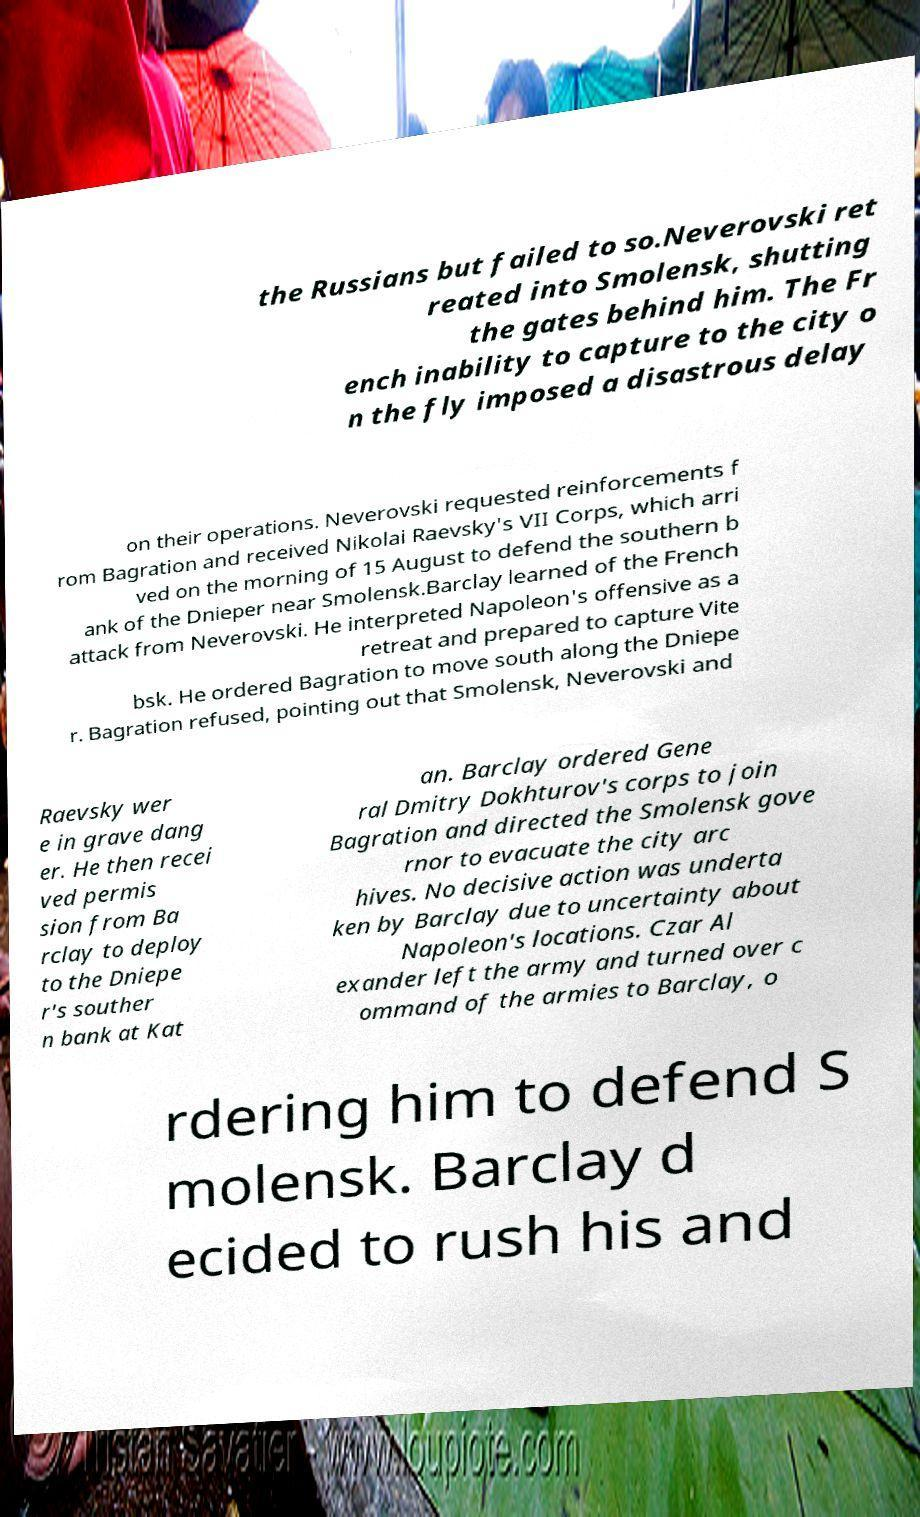Please identify and transcribe the text found in this image. the Russians but failed to so.Neverovski ret reated into Smolensk, shutting the gates behind him. The Fr ench inability to capture to the city o n the fly imposed a disastrous delay on their operations. Neverovski requested reinforcements f rom Bagration and received Nikolai Raevsky's VII Corps, which arri ved on the morning of 15 August to defend the southern b ank of the Dnieper near Smolensk.Barclay learned of the French attack from Neverovski. He interpreted Napoleon's offensive as a retreat and prepared to capture Vite bsk. He ordered Bagration to move south along the Dniepe r. Bagration refused, pointing out that Smolensk, Neverovski and Raevsky wer e in grave dang er. He then recei ved permis sion from Ba rclay to deploy to the Dniepe r's souther n bank at Kat an. Barclay ordered Gene ral Dmitry Dokhturov's corps to join Bagration and directed the Smolensk gove rnor to evacuate the city arc hives. No decisive action was underta ken by Barclay due to uncertainty about Napoleon's locations. Czar Al exander left the army and turned over c ommand of the armies to Barclay, o rdering him to defend S molensk. Barclay d ecided to rush his and 